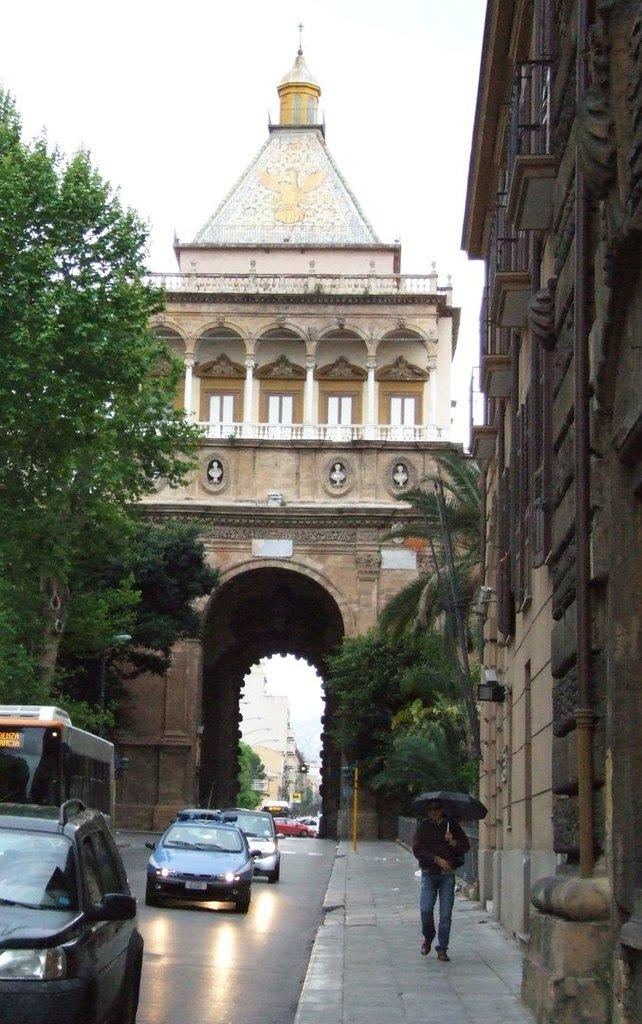What is the man in the image holding? The man in the image is holding an umbrella. What can be seen at the bottom side of the image? There are vehicles at the bottom side of the image. What type of transportation is present in the image? There is a subway in the image. What architectural feature is present in the image? There is an arch in the image. What is visible in the background of the image? There are buildings, trees, and the sky visible in the background of the image. What type of book is the man reading under the umbrella in the image? There is no book present in the image; the man is holding an umbrella. Is there a gun visible in the image? No, there is no gun present in the image. 